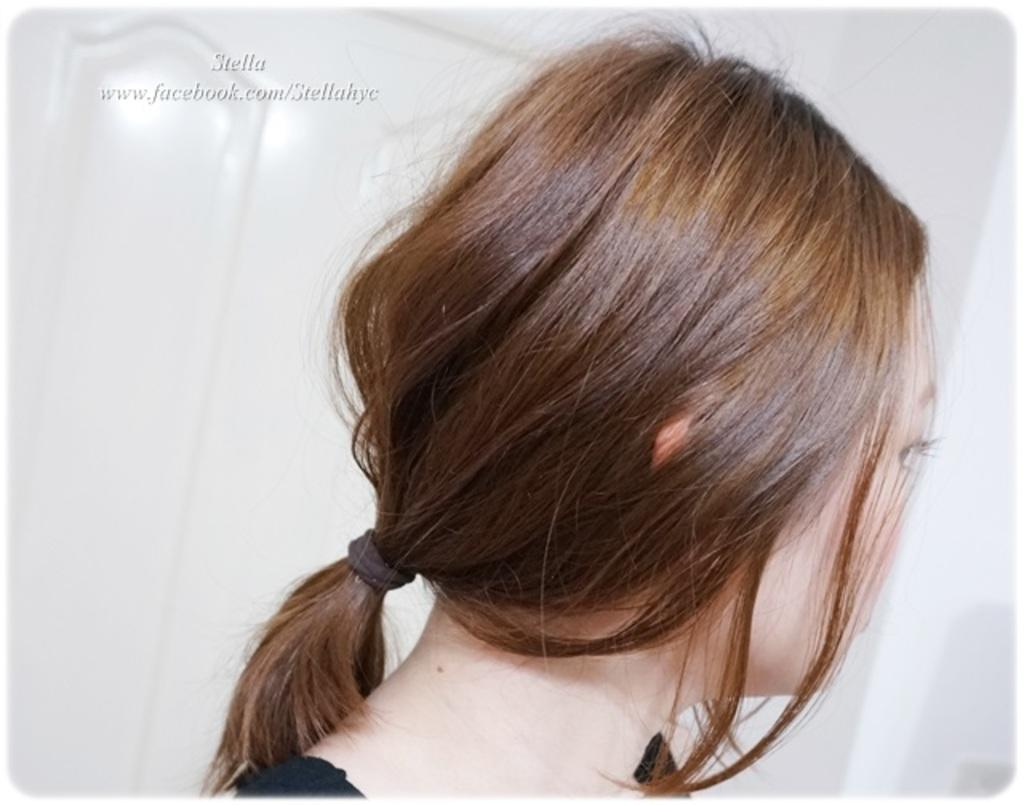What is the main subject of the image? There is a person in the image. Can you describe the person's appearance? The person has a rubber band tied to her hair. What is the color of the background in the image? The background of the image is white. Is there any additional information or branding on the image? Yes, there is a watermark on the image. What type of copper object can be seen in the person's hand in the image? There is no copper object present in the person's hand or anywhere else in the image. Can you describe the field where the person is standing in the image? There is no field present in the image; the background is white. 